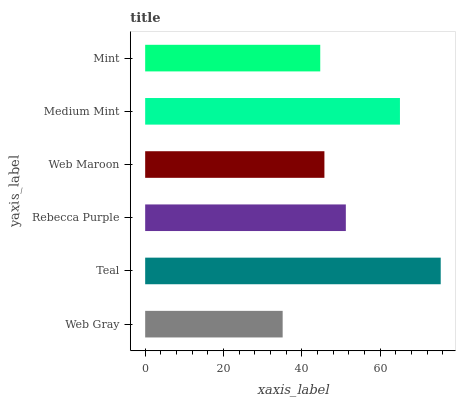Is Web Gray the minimum?
Answer yes or no. Yes. Is Teal the maximum?
Answer yes or no. Yes. Is Rebecca Purple the minimum?
Answer yes or no. No. Is Rebecca Purple the maximum?
Answer yes or no. No. Is Teal greater than Rebecca Purple?
Answer yes or no. Yes. Is Rebecca Purple less than Teal?
Answer yes or no. Yes. Is Rebecca Purple greater than Teal?
Answer yes or no. No. Is Teal less than Rebecca Purple?
Answer yes or no. No. Is Rebecca Purple the high median?
Answer yes or no. Yes. Is Web Maroon the low median?
Answer yes or no. Yes. Is Web Gray the high median?
Answer yes or no. No. Is Teal the low median?
Answer yes or no. No. 